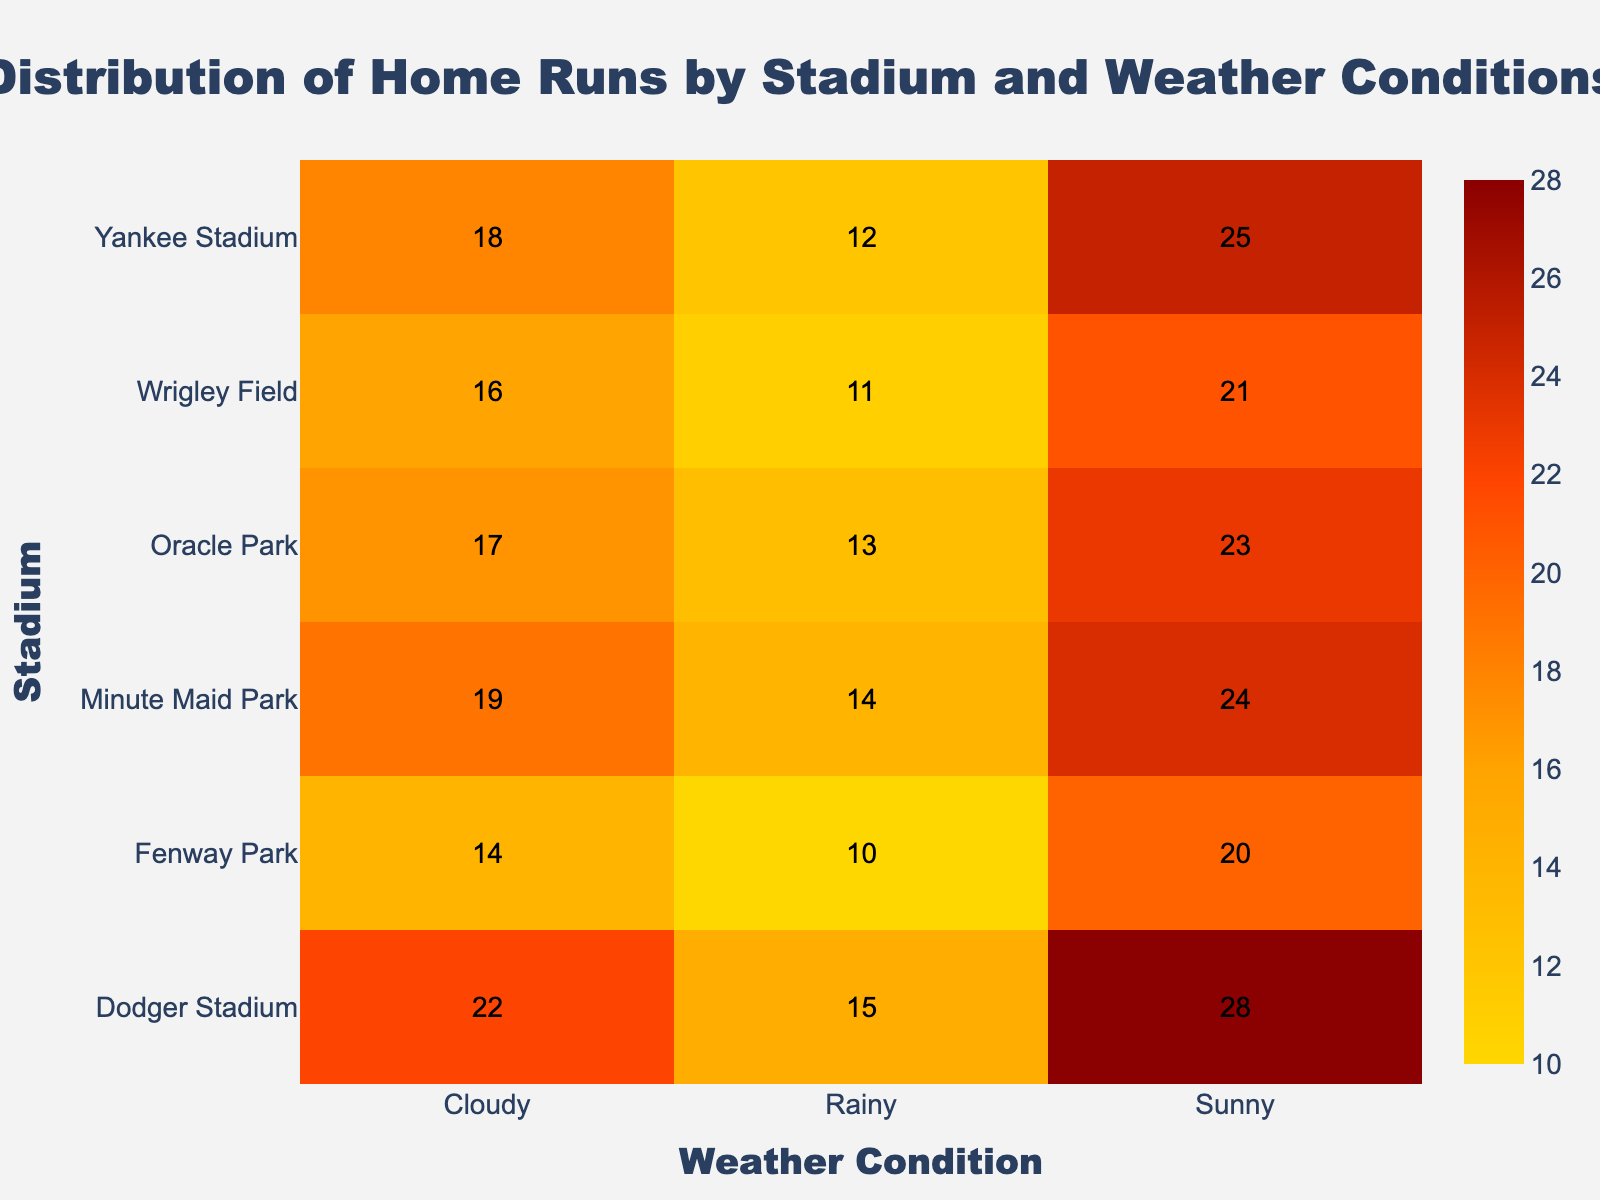What is the title of the heatmap? The title is written at the top center of the heatmap in a larger and bold font.
Answer: Distribution of Home Runs by Stadium and Weather Conditions Which stadium has the highest number of home runs under sunny conditions? Look at the row labeled "Sunny" and find the highest value. The highest number of home runs under sunny conditions is 28 at Dodger Stadium.
Answer: Dodger Stadium How many more home runs are scored at Fenway Park on sunny days compared to rainy days? Find the values for Fenway Park under sunny (20) and rainy (10) conditions. Subtract the rainy day number from the sunny day number. 20 - 10 = 10.
Answer: 10 What is the total number of home runs hit in cloudy weather across all stadiums? Add the values under the "Cloudy" column. 18 + 14 + 22 + 16 + 17 + 19 = 106
Answer: 106 Which stadium has the lowest number of home runs under any weather condition and which condition is it? Look for the smallest number in the entire heatmap. The lowest value is 10, found in Fenway Park under rainy conditions.
Answer: Fenway Park, Rainy How do home runs at Minute Maid Park on sunny days compare to Oracle Park on the same condition? Find the home runs under sunny conditions for Minute Maid Park (24) and Oracle Park (23). Compare their values. 24 is slightly higher than 23.
Answer: Minute Maid Park has slightly more Compare the number of home runs at Wrigley Field and Yankee Stadium on cloudy days. Which has more? Locate the values for Wrigley Field (16) and Yankee Stadium (18) under cloudy conditions and compare them. 18 is greater than 16.
Answer: Yankee Stadium What is the average number of home runs hit at Dodger Stadium across all weather conditions? Calculate the average by adding all values for Dodger Stadium and then divide by 3. (28 + 22 + 15) / 3 = 65 / 3 ≈ 21.67
Answer: Approximately 21.67 Are home runs more frequent on sunny days or rainy days at Oracle Park? Compare the home runs for sunny (23) and rainy (13) days. 23 is greater than 13, so more home runs are hit on sunny days.
Answer: Sunny days Which stadium shows the smallest difference between home runs hit on sunny and cloudy days? Calculate the difference between sunny and cloudy values for each stadium and find the smallest difference.
Answer: Wrigley Field (21 - 16 = 5) 